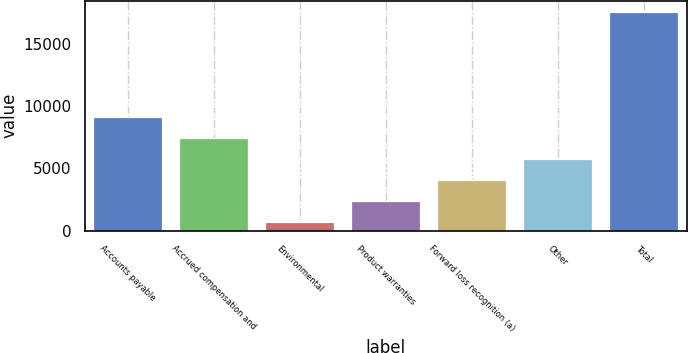Convert chart to OTSL. <chart><loc_0><loc_0><loc_500><loc_500><bar_chart><fcel>Accounts payable<fcel>Accrued compensation and<fcel>Environmental<fcel>Product warranties<fcel>Forward loss recognition (a)<fcel>Other<fcel>Total<nl><fcel>9159<fcel>7473.4<fcel>731<fcel>2416.6<fcel>4102.2<fcel>5787.8<fcel>17587<nl></chart> 